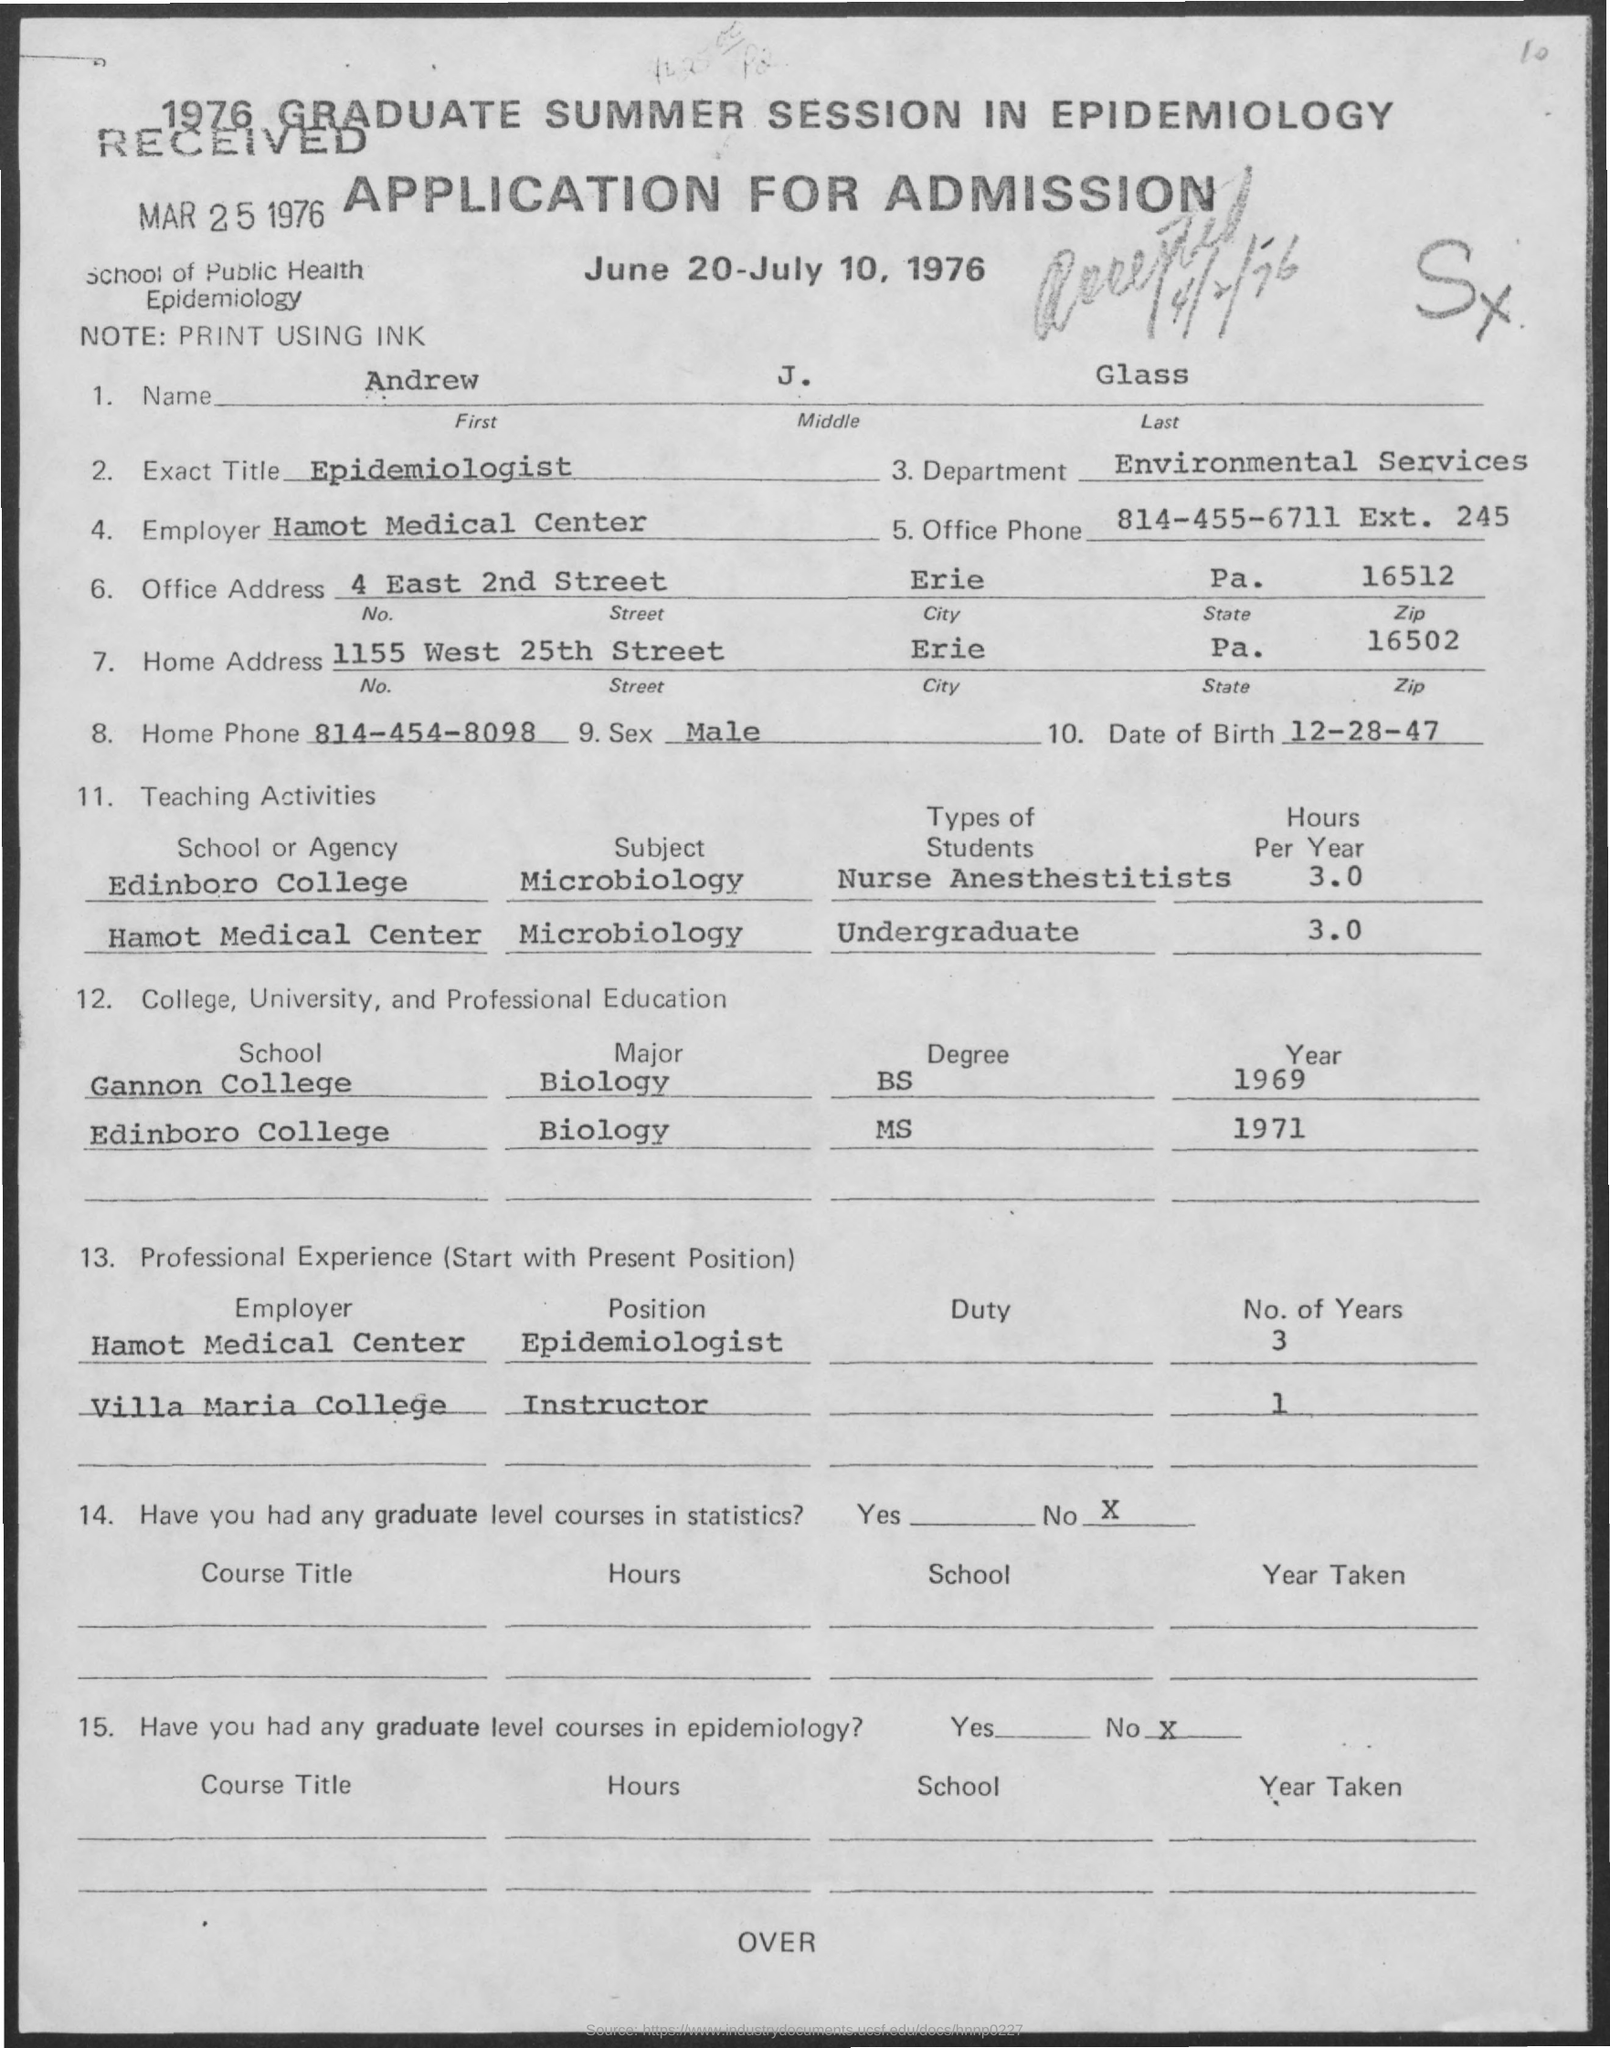Mention a couple of crucial points in this snapshot. The exact title of the position is an epidemiologist. On December 28, 1947, Andrew was born. The home phone number is 814-454-8098. The Zip Code for the Office Address is 16512. 